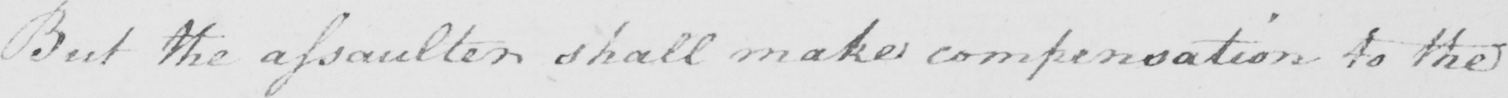What is written in this line of handwriting? But the assaulter shall make compensation to the 